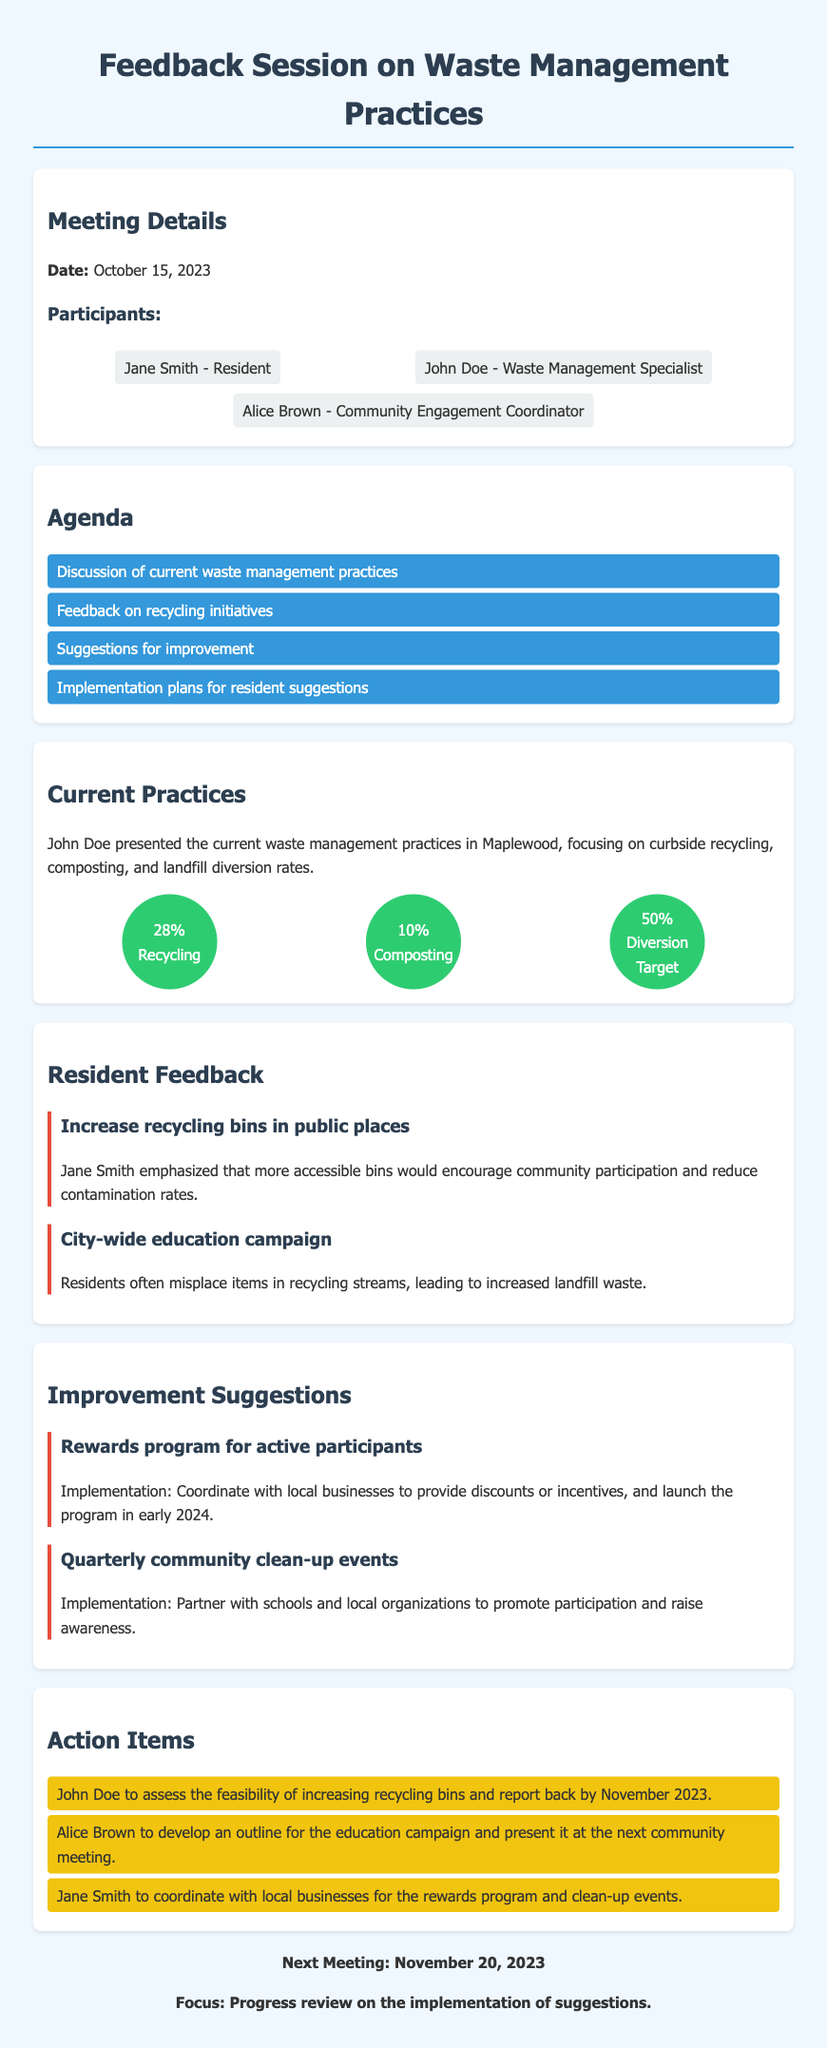What is the date of the meeting? The date of the meeting is clearly stated at the beginning of the document as October 15, 2023.
Answer: October 15, 2023 Who presented the current waste management practices? The document states that John Doe presented the current waste management practices during the meeting.
Answer: John Doe What percentage of waste is allocated for recycling? The document provides specific statistics where it mentions the recycling rate as 28%.
Answer: 28% What suggestion was made to increase community participation? The suggestion made was to increase recycling bins in public places, as highlighted in the resident feedback section.
Answer: Increase recycling bins in public places How many action items were listed in total? The action items section contains three specific items assigned to participants, indicating the number of action items.
Answer: Three What is the focus of the next meeting? The document outlines that the next meeting will focus on the progress review on the implementation of suggestions.
Answer: Progress review on the implementation of suggestions What is the proposed implementation time for the rewards program? The document indicates that the rewards program is intended to launch in early 2024.
Answer: Early 2024 Who is responsible for developing the education campaign outline? According to the action items section, Alice Brown is responsible for developing the outline for the education campaign.
Answer: Alice Brown 